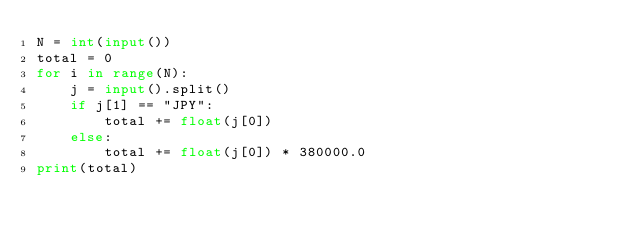<code> <loc_0><loc_0><loc_500><loc_500><_Python_>N = int(input())
total = 0
for i in range(N):
    j = input().split()
    if j[1] == "JPY":
        total += float(j[0])
    else:
        total += float(j[0]) * 380000.0
print(total)
</code> 